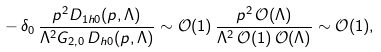Convert formula to latex. <formula><loc_0><loc_0><loc_500><loc_500>- \, \delta _ { 0 } \, \frac { p ^ { 2 } D _ { 1 h 0 } ( p , \Lambda ) } { \Lambda ^ { 2 } G _ { 2 , 0 } \, D _ { h 0 } ( p , \Lambda ) } \sim \mathcal { O } ( 1 ) \, \frac { p ^ { 2 } \, \mathcal { O } ( \Lambda ) } { \Lambda ^ { 2 } \, \mathcal { O } ( 1 ) \, \mathcal { O } ( \Lambda ) } \sim \mathcal { O } ( 1 ) ,</formula> 